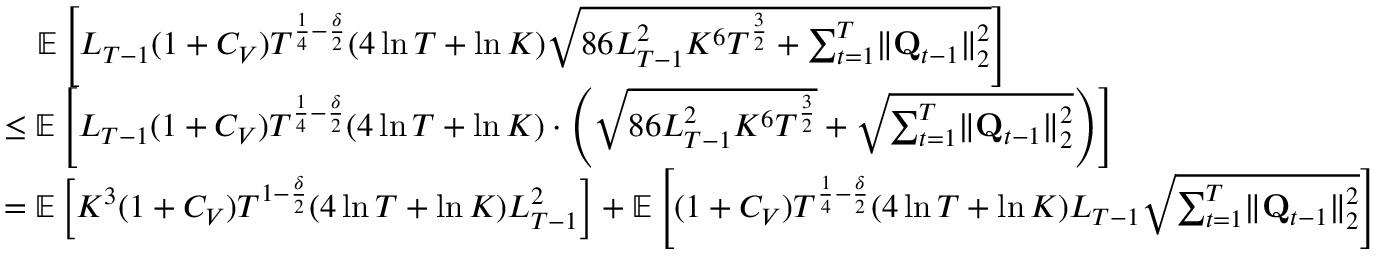Convert formula to latex. <formula><loc_0><loc_0><loc_500><loc_500>\begin{array} { r l } & { \quad \mathbb { E } \left [ L _ { T - 1 } ( 1 + C _ { V } ) T ^ { \frac { 1 } { 4 } - \frac { \delta } { 2 } } ( 4 \ln T + \ln K ) \sqrt { 8 6 L _ { T - 1 } ^ { 2 } K ^ { 6 } T ^ { \frac { 3 } { 2 } } + \sum _ { t = 1 } ^ { T } \| \mathbf Q _ { t - 1 } \| _ { 2 } ^ { 2 } } \right ] } \\ & { \leq \mathbb { E } \left [ L _ { T - 1 } ( 1 + C _ { V } ) T ^ { \frac { 1 } { 4 } - \frac { \delta } { 2 } } ( 4 \ln T + \ln K ) \cdot \left ( \sqrt { 8 6 L _ { T - 1 } ^ { 2 } K ^ { 6 } T ^ { \frac { 3 } { 2 } } } + \sqrt { \sum _ { t = 1 } ^ { T } \| \mathbf Q _ { t - 1 } \| _ { 2 } ^ { 2 } } \right ) \right ] } \\ & { = \mathbb { E } \left [ K ^ { 3 } ( 1 + C _ { V } ) T ^ { 1 - \frac { \delta } { 2 } } ( 4 \ln T + \ln K ) L _ { T - 1 } ^ { 2 } \right ] + \mathbb { E } \left [ ( 1 + C _ { V } ) T ^ { \frac { 1 } { 4 } - \frac { \delta } { 2 } } ( 4 \ln T + \ln K ) L _ { T - 1 } \sqrt { \sum _ { t = 1 } ^ { T } \| \mathbf Q _ { t - 1 } \| _ { 2 } ^ { 2 } } \right ] } \end{array}</formula> 